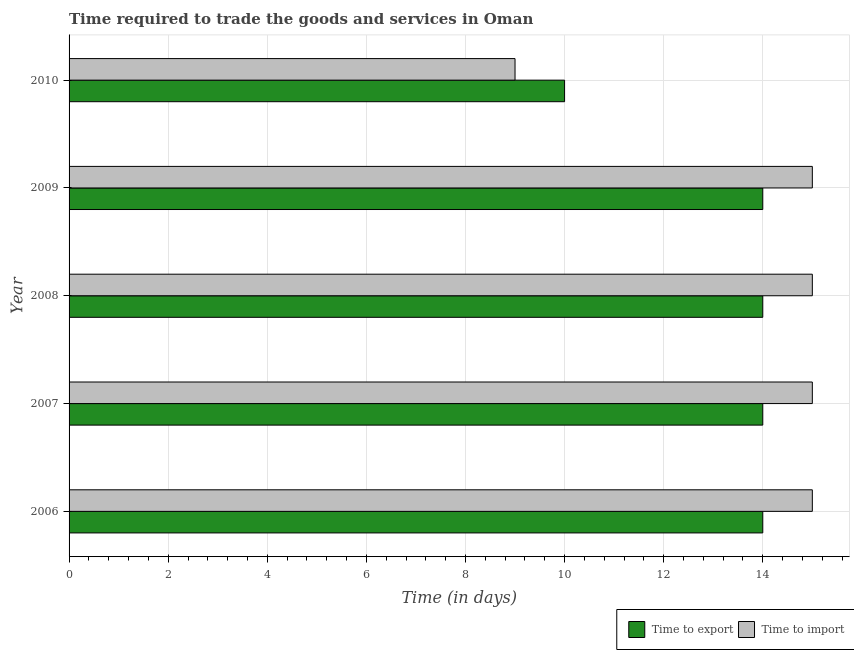How many bars are there on the 5th tick from the bottom?
Offer a very short reply. 2. In how many cases, is the number of bars for a given year not equal to the number of legend labels?
Keep it short and to the point. 0. What is the time to export in 2006?
Offer a terse response. 14. Across all years, what is the maximum time to import?
Your answer should be very brief. 15. Across all years, what is the minimum time to export?
Offer a very short reply. 10. What is the total time to import in the graph?
Make the answer very short. 69. What is the difference between the time to export in 2006 and the time to import in 2010?
Your answer should be very brief. 5. In the year 2009, what is the difference between the time to export and time to import?
Offer a terse response. -1. In how many years, is the time to export greater than 7.6 days?
Make the answer very short. 5. What is the ratio of the time to import in 2009 to that in 2010?
Your response must be concise. 1.67. Is the difference between the time to export in 2006 and 2009 greater than the difference between the time to import in 2006 and 2009?
Your response must be concise. No. What is the difference between the highest and the lowest time to export?
Ensure brevity in your answer.  4. In how many years, is the time to export greater than the average time to export taken over all years?
Your answer should be compact. 4. Is the sum of the time to import in 2006 and 2010 greater than the maximum time to export across all years?
Ensure brevity in your answer.  Yes. What does the 2nd bar from the top in 2008 represents?
Provide a short and direct response. Time to export. What does the 2nd bar from the bottom in 2008 represents?
Give a very brief answer. Time to import. Are all the bars in the graph horizontal?
Ensure brevity in your answer.  Yes. How many years are there in the graph?
Provide a succinct answer. 5. What is the difference between two consecutive major ticks on the X-axis?
Give a very brief answer. 2. How are the legend labels stacked?
Offer a terse response. Horizontal. What is the title of the graph?
Keep it short and to the point. Time required to trade the goods and services in Oman. What is the label or title of the X-axis?
Offer a terse response. Time (in days). What is the Time (in days) of Time to export in 2008?
Your response must be concise. 14. What is the Time (in days) of Time to import in 2008?
Offer a terse response. 15. What is the Time (in days) in Time to export in 2009?
Ensure brevity in your answer.  14. What is the Time (in days) of Time to import in 2010?
Provide a succinct answer. 9. Across all years, what is the minimum Time (in days) in Time to import?
Make the answer very short. 9. What is the total Time (in days) of Time to import in the graph?
Make the answer very short. 69. What is the difference between the Time (in days) of Time to export in 2006 and that in 2009?
Keep it short and to the point. 0. What is the difference between the Time (in days) in Time to export in 2006 and that in 2010?
Your answer should be compact. 4. What is the difference between the Time (in days) in Time to export in 2007 and that in 2008?
Your answer should be compact. 0. What is the difference between the Time (in days) in Time to import in 2007 and that in 2008?
Make the answer very short. 0. What is the difference between the Time (in days) in Time to import in 2007 and that in 2010?
Ensure brevity in your answer.  6. What is the difference between the Time (in days) in Time to import in 2008 and that in 2009?
Provide a succinct answer. 0. What is the difference between the Time (in days) in Time to import in 2008 and that in 2010?
Ensure brevity in your answer.  6. What is the difference between the Time (in days) of Time to export in 2009 and that in 2010?
Provide a short and direct response. 4. What is the difference between the Time (in days) of Time to export in 2006 and the Time (in days) of Time to import in 2007?
Offer a very short reply. -1. What is the difference between the Time (in days) of Time to export in 2006 and the Time (in days) of Time to import in 2009?
Your response must be concise. -1. What is the difference between the Time (in days) of Time to export in 2007 and the Time (in days) of Time to import in 2010?
Your answer should be compact. 5. What is the average Time (in days) in Time to import per year?
Offer a terse response. 13.8. In the year 2006, what is the difference between the Time (in days) of Time to export and Time (in days) of Time to import?
Your answer should be compact. -1. In the year 2007, what is the difference between the Time (in days) in Time to export and Time (in days) in Time to import?
Your response must be concise. -1. In the year 2009, what is the difference between the Time (in days) of Time to export and Time (in days) of Time to import?
Offer a very short reply. -1. What is the ratio of the Time (in days) of Time to import in 2006 to that in 2007?
Make the answer very short. 1. What is the ratio of the Time (in days) of Time to import in 2006 to that in 2008?
Your answer should be very brief. 1. What is the ratio of the Time (in days) in Time to export in 2006 to that in 2009?
Ensure brevity in your answer.  1. What is the ratio of the Time (in days) in Time to import in 2006 to that in 2009?
Offer a terse response. 1. What is the ratio of the Time (in days) of Time to export in 2006 to that in 2010?
Your answer should be very brief. 1.4. What is the ratio of the Time (in days) in Time to import in 2007 to that in 2010?
Keep it short and to the point. 1.67. What is the ratio of the Time (in days) in Time to import in 2008 to that in 2009?
Offer a very short reply. 1. What is the ratio of the Time (in days) in Time to import in 2008 to that in 2010?
Keep it short and to the point. 1.67. What is the ratio of the Time (in days) of Time to export in 2009 to that in 2010?
Offer a terse response. 1.4. What is the difference between the highest and the second highest Time (in days) in Time to import?
Give a very brief answer. 0. What is the difference between the highest and the lowest Time (in days) of Time to import?
Offer a terse response. 6. 